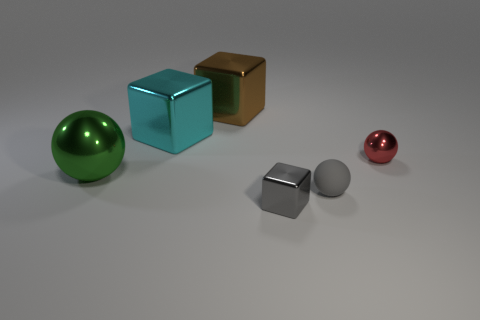Subtract all large cubes. How many cubes are left? 1 Subtract 2 cubes. How many cubes are left? 1 Subtract all gray blocks. How many blocks are left? 2 Add 4 large brown blocks. How many objects exist? 10 Subtract 1 green balls. How many objects are left? 5 Subtract all yellow cubes. Subtract all brown spheres. How many cubes are left? 3 Subtract all cyan cylinders. How many blue cubes are left? 0 Subtract all small gray shiny balls. Subtract all tiny gray blocks. How many objects are left? 5 Add 6 tiny gray metal blocks. How many tiny gray metal blocks are left? 7 Add 5 large objects. How many large objects exist? 8 